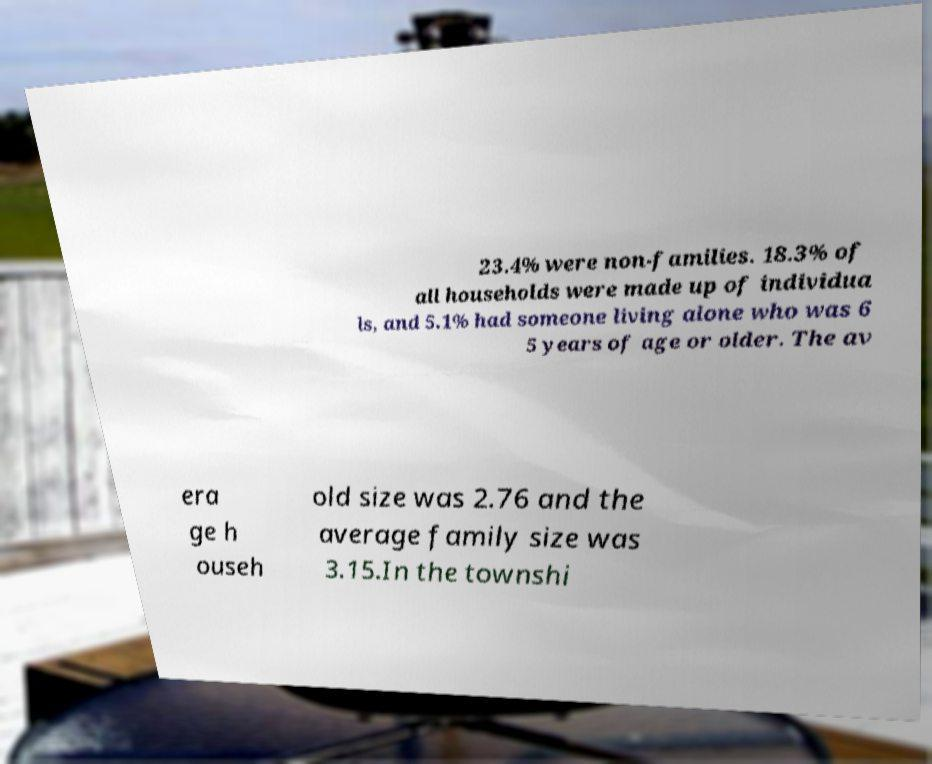Can you accurately transcribe the text from the provided image for me? 23.4% were non-families. 18.3% of all households were made up of individua ls, and 5.1% had someone living alone who was 6 5 years of age or older. The av era ge h ouseh old size was 2.76 and the average family size was 3.15.In the townshi 